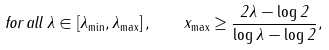Convert formula to latex. <formula><loc_0><loc_0><loc_500><loc_500>f o r \, a l l \, \lambda \in \left [ \lambda _ { \min } , \lambda _ { \max } \right ] , \quad x _ { \max } \geq \frac { 2 \lambda - \log 2 } { \log \lambda - \log 2 } ,</formula> 